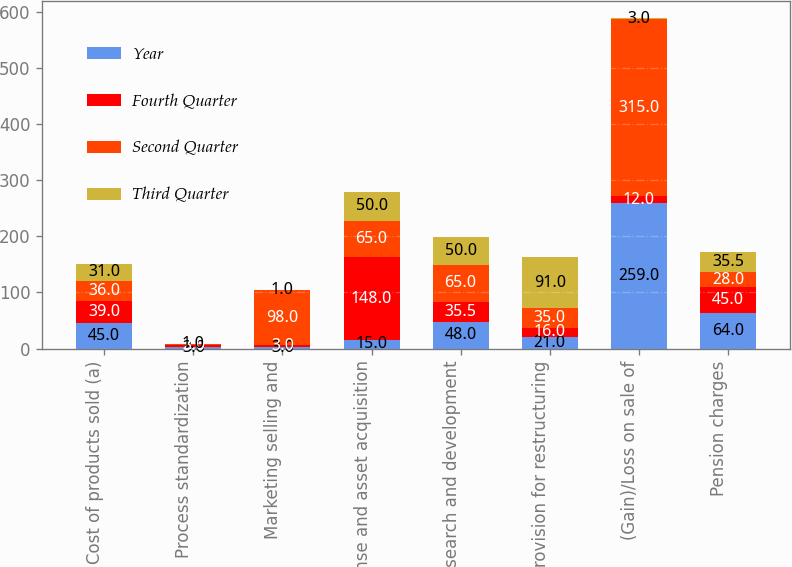Convert chart to OTSL. <chart><loc_0><loc_0><loc_500><loc_500><stacked_bar_chart><ecel><fcel>Cost of products sold (a)<fcel>Process standardization<fcel>Marketing selling and<fcel>License and asset acquisition<fcel>Research and development<fcel>Provision for restructuring<fcel>(Gain)/Loss on sale of<fcel>Pension charges<nl><fcel>Year<fcel>45<fcel>3<fcel>3<fcel>15<fcel>48<fcel>21<fcel>259<fcel>64<nl><fcel>Fourth Quarter<fcel>39<fcel>3<fcel>3<fcel>148<fcel>35.5<fcel>16<fcel>12<fcel>45<nl><fcel>Second Quarter<fcel>36<fcel>2<fcel>98<fcel>65<fcel>65<fcel>35<fcel>315<fcel>28<nl><fcel>Third Quarter<fcel>31<fcel>1<fcel>1<fcel>50<fcel>50<fcel>91<fcel>3<fcel>35.5<nl></chart> 